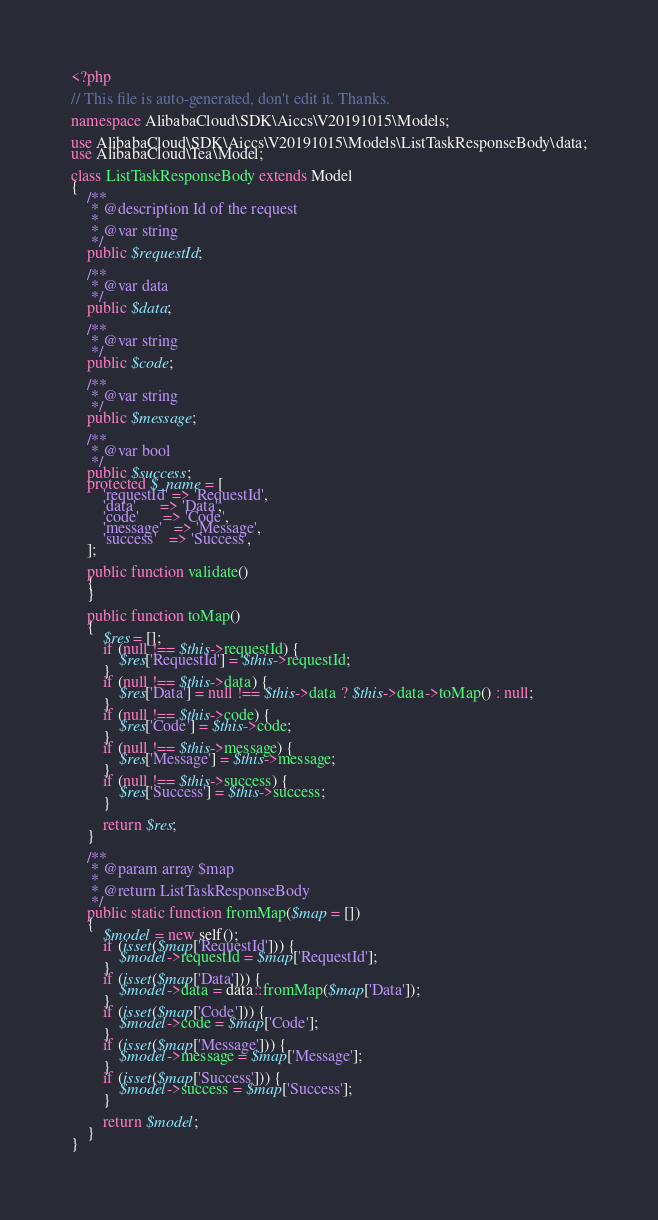<code> <loc_0><loc_0><loc_500><loc_500><_PHP_><?php

// This file is auto-generated, don't edit it. Thanks.

namespace AlibabaCloud\SDK\Aiccs\V20191015\Models;

use AlibabaCloud\SDK\Aiccs\V20191015\Models\ListTaskResponseBody\data;
use AlibabaCloud\Tea\Model;

class ListTaskResponseBody extends Model
{
    /**
     * @description Id of the request
     *
     * @var string
     */
    public $requestId;

    /**
     * @var data
     */
    public $data;

    /**
     * @var string
     */
    public $code;

    /**
     * @var string
     */
    public $message;

    /**
     * @var bool
     */
    public $success;
    protected $_name = [
        'requestId' => 'RequestId',
        'data'      => 'Data',
        'code'      => 'Code',
        'message'   => 'Message',
        'success'   => 'Success',
    ];

    public function validate()
    {
    }

    public function toMap()
    {
        $res = [];
        if (null !== $this->requestId) {
            $res['RequestId'] = $this->requestId;
        }
        if (null !== $this->data) {
            $res['Data'] = null !== $this->data ? $this->data->toMap() : null;
        }
        if (null !== $this->code) {
            $res['Code'] = $this->code;
        }
        if (null !== $this->message) {
            $res['Message'] = $this->message;
        }
        if (null !== $this->success) {
            $res['Success'] = $this->success;
        }

        return $res;
    }

    /**
     * @param array $map
     *
     * @return ListTaskResponseBody
     */
    public static function fromMap($map = [])
    {
        $model = new self();
        if (isset($map['RequestId'])) {
            $model->requestId = $map['RequestId'];
        }
        if (isset($map['Data'])) {
            $model->data = data::fromMap($map['Data']);
        }
        if (isset($map['Code'])) {
            $model->code = $map['Code'];
        }
        if (isset($map['Message'])) {
            $model->message = $map['Message'];
        }
        if (isset($map['Success'])) {
            $model->success = $map['Success'];
        }

        return $model;
    }
}
</code> 